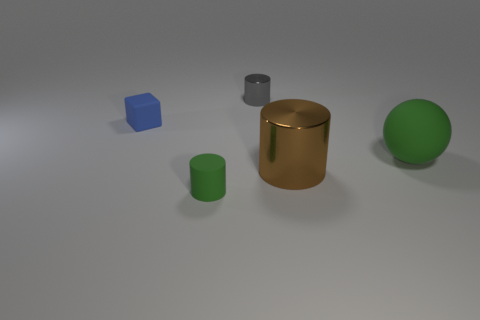Add 3 brown matte cylinders. How many objects exist? 8 Subtract all cubes. How many objects are left? 4 Subtract all spheres. Subtract all big matte objects. How many objects are left? 3 Add 1 big shiny cylinders. How many big shiny cylinders are left? 2 Add 3 tiny yellow objects. How many tiny yellow objects exist? 3 Subtract 0 yellow blocks. How many objects are left? 5 